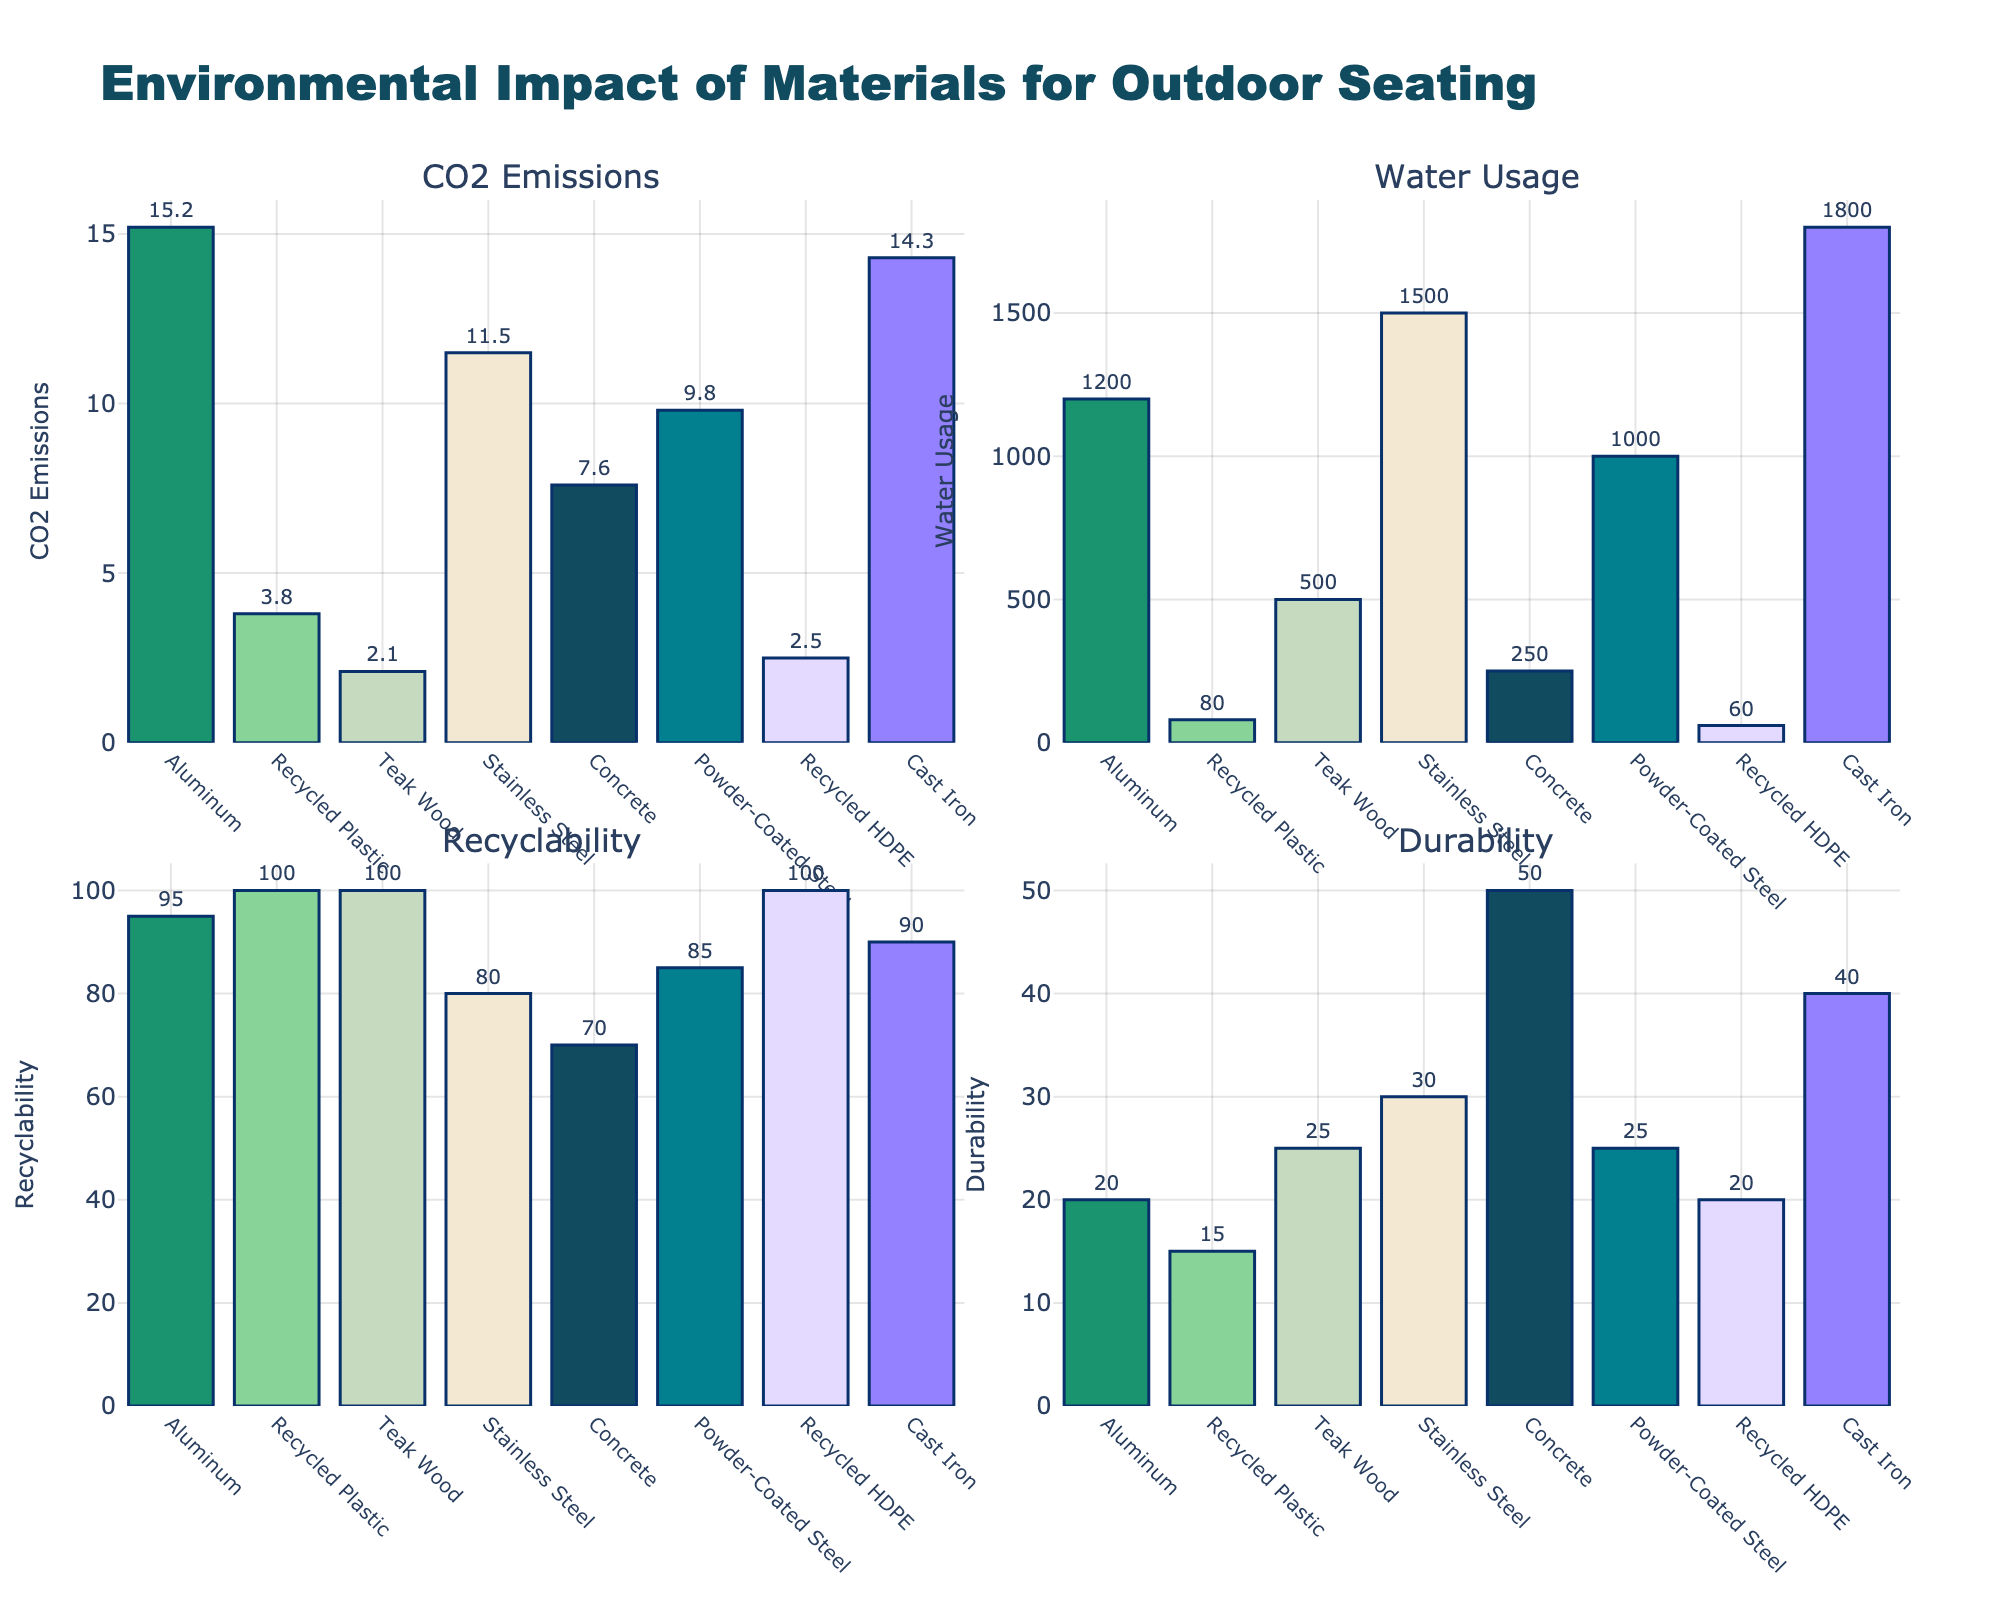Which material has the highest CO2 Emissions per unit? The subplot titled "CO2 Emissions" shows the bar heights for different materials. The material with the highest bar is Cast Iron.
Answer: Cast Iron How many years does Concrete last? The subplot titled "Durability" lists the durability values in years for different materials. The bar for Concrete has a label showing 50 years.
Answer: 50 Which two materials have the highest Recyclability percentage? The subplot titled "Recyclability" shows the percentages for all materials. Both Recycled Plastic and Teak Wood have labels of 100%.
Answer: Recycled Plastic, Teak Wood Which material uses the least water? The subplot titled "Water Usage" displays water usage for different materials. The shortest bar belongs to Recycled HDPE, with 60 liters per unit.
Answer: Recycled HDPE Calculate the average CO2 Emissions for Aluminum, Recycled Plastic, and Stainless Steel. The CO2 Emissions for Aluminum is 15.2 kg/unit, Recycled Plastic is 3.8 kg/unit, and Stainless Steel is 11.5 kg/unit. (15.2 + 3.8 + 11.5)/3 = 10.17 kg/unit.
Answer: 10.17 Which material has a higher water usage, Teak Wood or Stainless Steel, and by how much? On the "Water Usage" subplot, Teak Wood shows 500 L/unit and Stainless Steel shows 1500 L/unit. The difference is 1500 - 500 = 1000 L/unit.
Answer: Stainless Steel, 1000 L/unit What is the total durability of all the materials combined? Summing up all the durability values: Aluminum (20), Recycled Plastic (15), Teak Wood (25), Stainless Steel (30), Concrete (50), Powder-Coated Steel (25), Recycled HDPE (20), and Cast Iron (40). Total = 20 + 15 + 25 + 30 + 50 + 25 + 20 + 40 = 225 years.
Answer: 225 Which material is both 100% recyclable and has more than 20 years of durability? Out of materials listed, Teak Wood and Recycled HDPE are 100% recyclable. However, only Teak Wood has a durability of more than 20 years (25 years, while Recycled HDPE has 20 years).
Answer: Teak Wood Rank the materials from highest to lowest in terms of Recyclability percentage. The "Recyclability" subplot shows: Recycled Plastic (100%), Teak Wood (100%), Recycled HDPE (100%), Cast Iron (90%), Powder-Coated Steel (85%), Stainless Steel (80%), Concrete (70%), and Aluminum (95%). So, ranking them: Recycled Plastic/Teak Wood/Recycled HDPE, Cast Iron, Aluminum, Powder-Coated Steel, Stainless Steel, Concrete.
Answer: Recycled Plastic/Teak Wood/Recycled HDPE, Cast Iron, Aluminum, Powder-Coated Steel, Stainless Steel, Concrete What is the difference in CO2 Emissions between the material with the highest and the lowest emissions? The highest CO2 Emissions is from Cast Iron (14.3 kg/unit) and the lowest is from Teak Wood (2.1 kg/unit). The difference is 14.3 - 2.1 = 12.2 kg/unit.
Answer: 12.2 kg/unit 